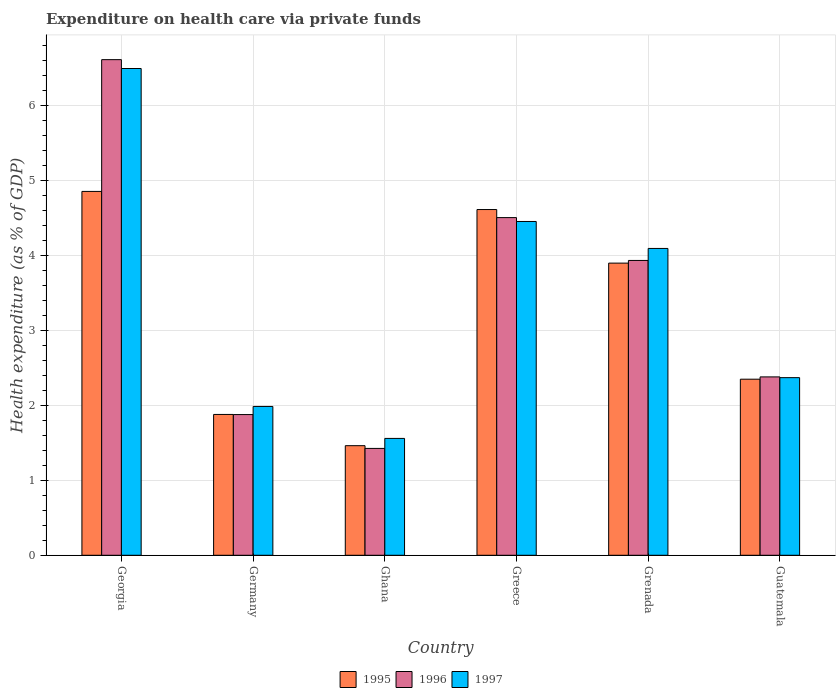How many groups of bars are there?
Ensure brevity in your answer.  6. Are the number of bars per tick equal to the number of legend labels?
Offer a terse response. Yes. How many bars are there on the 1st tick from the left?
Provide a short and direct response. 3. What is the label of the 6th group of bars from the left?
Offer a terse response. Guatemala. In how many cases, is the number of bars for a given country not equal to the number of legend labels?
Offer a very short reply. 0. What is the expenditure made on health care in 1996 in Grenada?
Provide a succinct answer. 3.94. Across all countries, what is the maximum expenditure made on health care in 1996?
Give a very brief answer. 6.62. Across all countries, what is the minimum expenditure made on health care in 1995?
Ensure brevity in your answer.  1.46. In which country was the expenditure made on health care in 1995 maximum?
Your answer should be very brief. Georgia. What is the total expenditure made on health care in 1995 in the graph?
Provide a short and direct response. 19.07. What is the difference between the expenditure made on health care in 1997 in Germany and that in Ghana?
Offer a very short reply. 0.43. What is the difference between the expenditure made on health care in 1997 in Georgia and the expenditure made on health care in 1995 in Greece?
Offer a very short reply. 1.88. What is the average expenditure made on health care in 1995 per country?
Keep it short and to the point. 3.18. What is the difference between the expenditure made on health care of/in 1995 and expenditure made on health care of/in 1997 in Grenada?
Your response must be concise. -0.2. In how many countries, is the expenditure made on health care in 1995 greater than 6.2 %?
Your answer should be compact. 0. What is the ratio of the expenditure made on health care in 1997 in Georgia to that in Grenada?
Provide a short and direct response. 1.59. Is the difference between the expenditure made on health care in 1995 in Ghana and Grenada greater than the difference between the expenditure made on health care in 1997 in Ghana and Grenada?
Keep it short and to the point. Yes. What is the difference between the highest and the second highest expenditure made on health care in 1996?
Your response must be concise. -0.57. What is the difference between the highest and the lowest expenditure made on health care in 1997?
Your response must be concise. 4.94. In how many countries, is the expenditure made on health care in 1995 greater than the average expenditure made on health care in 1995 taken over all countries?
Make the answer very short. 3. Is the sum of the expenditure made on health care in 1997 in Ghana and Greece greater than the maximum expenditure made on health care in 1996 across all countries?
Provide a succinct answer. No. What does the 2nd bar from the right in Germany represents?
Offer a terse response. 1996. How many bars are there?
Offer a terse response. 18. Are all the bars in the graph horizontal?
Ensure brevity in your answer.  No. How many countries are there in the graph?
Make the answer very short. 6. What is the difference between two consecutive major ticks on the Y-axis?
Ensure brevity in your answer.  1. Are the values on the major ticks of Y-axis written in scientific E-notation?
Your answer should be compact. No. Does the graph contain any zero values?
Your answer should be compact. No. How many legend labels are there?
Give a very brief answer. 3. What is the title of the graph?
Provide a short and direct response. Expenditure on health care via private funds. Does "1967" appear as one of the legend labels in the graph?
Offer a very short reply. No. What is the label or title of the Y-axis?
Make the answer very short. Health expenditure (as % of GDP). What is the Health expenditure (as % of GDP) in 1995 in Georgia?
Offer a very short reply. 4.86. What is the Health expenditure (as % of GDP) in 1996 in Georgia?
Keep it short and to the point. 6.62. What is the Health expenditure (as % of GDP) in 1997 in Georgia?
Your answer should be very brief. 6.5. What is the Health expenditure (as % of GDP) in 1995 in Germany?
Your response must be concise. 1.88. What is the Health expenditure (as % of GDP) of 1996 in Germany?
Ensure brevity in your answer.  1.88. What is the Health expenditure (as % of GDP) in 1997 in Germany?
Your response must be concise. 1.99. What is the Health expenditure (as % of GDP) in 1995 in Ghana?
Make the answer very short. 1.46. What is the Health expenditure (as % of GDP) of 1996 in Ghana?
Your response must be concise. 1.43. What is the Health expenditure (as % of GDP) in 1997 in Ghana?
Ensure brevity in your answer.  1.56. What is the Health expenditure (as % of GDP) of 1995 in Greece?
Give a very brief answer. 4.62. What is the Health expenditure (as % of GDP) of 1996 in Greece?
Your answer should be compact. 4.51. What is the Health expenditure (as % of GDP) of 1997 in Greece?
Your answer should be very brief. 4.46. What is the Health expenditure (as % of GDP) in 1995 in Grenada?
Give a very brief answer. 3.9. What is the Health expenditure (as % of GDP) in 1996 in Grenada?
Give a very brief answer. 3.94. What is the Health expenditure (as % of GDP) in 1997 in Grenada?
Provide a succinct answer. 4.1. What is the Health expenditure (as % of GDP) in 1995 in Guatemala?
Provide a short and direct response. 2.35. What is the Health expenditure (as % of GDP) in 1996 in Guatemala?
Give a very brief answer. 2.38. What is the Health expenditure (as % of GDP) in 1997 in Guatemala?
Provide a short and direct response. 2.37. Across all countries, what is the maximum Health expenditure (as % of GDP) of 1995?
Keep it short and to the point. 4.86. Across all countries, what is the maximum Health expenditure (as % of GDP) in 1996?
Provide a succinct answer. 6.62. Across all countries, what is the maximum Health expenditure (as % of GDP) of 1997?
Your answer should be compact. 6.5. Across all countries, what is the minimum Health expenditure (as % of GDP) in 1995?
Keep it short and to the point. 1.46. Across all countries, what is the minimum Health expenditure (as % of GDP) of 1996?
Your answer should be compact. 1.43. Across all countries, what is the minimum Health expenditure (as % of GDP) of 1997?
Make the answer very short. 1.56. What is the total Health expenditure (as % of GDP) of 1995 in the graph?
Your answer should be compact. 19.07. What is the total Health expenditure (as % of GDP) in 1996 in the graph?
Give a very brief answer. 20.75. What is the total Health expenditure (as % of GDP) of 1997 in the graph?
Make the answer very short. 20.97. What is the difference between the Health expenditure (as % of GDP) of 1995 in Georgia and that in Germany?
Ensure brevity in your answer.  2.98. What is the difference between the Health expenditure (as % of GDP) in 1996 in Georgia and that in Germany?
Your answer should be very brief. 4.74. What is the difference between the Health expenditure (as % of GDP) of 1997 in Georgia and that in Germany?
Your answer should be compact. 4.51. What is the difference between the Health expenditure (as % of GDP) of 1995 in Georgia and that in Ghana?
Keep it short and to the point. 3.39. What is the difference between the Health expenditure (as % of GDP) in 1996 in Georgia and that in Ghana?
Give a very brief answer. 5.19. What is the difference between the Health expenditure (as % of GDP) of 1997 in Georgia and that in Ghana?
Provide a succinct answer. 4.94. What is the difference between the Health expenditure (as % of GDP) in 1995 in Georgia and that in Greece?
Give a very brief answer. 0.24. What is the difference between the Health expenditure (as % of GDP) in 1996 in Georgia and that in Greece?
Ensure brevity in your answer.  2.11. What is the difference between the Health expenditure (as % of GDP) of 1997 in Georgia and that in Greece?
Give a very brief answer. 2.04. What is the difference between the Health expenditure (as % of GDP) of 1995 in Georgia and that in Grenada?
Your answer should be compact. 0.96. What is the difference between the Health expenditure (as % of GDP) in 1996 in Georgia and that in Grenada?
Keep it short and to the point. 2.68. What is the difference between the Health expenditure (as % of GDP) in 1997 in Georgia and that in Grenada?
Make the answer very short. 2.4. What is the difference between the Health expenditure (as % of GDP) of 1995 in Georgia and that in Guatemala?
Give a very brief answer. 2.51. What is the difference between the Health expenditure (as % of GDP) in 1996 in Georgia and that in Guatemala?
Ensure brevity in your answer.  4.24. What is the difference between the Health expenditure (as % of GDP) of 1997 in Georgia and that in Guatemala?
Give a very brief answer. 4.13. What is the difference between the Health expenditure (as % of GDP) of 1995 in Germany and that in Ghana?
Offer a very short reply. 0.42. What is the difference between the Health expenditure (as % of GDP) of 1996 in Germany and that in Ghana?
Provide a succinct answer. 0.45. What is the difference between the Health expenditure (as % of GDP) of 1997 in Germany and that in Ghana?
Give a very brief answer. 0.43. What is the difference between the Health expenditure (as % of GDP) of 1995 in Germany and that in Greece?
Provide a short and direct response. -2.74. What is the difference between the Health expenditure (as % of GDP) in 1996 in Germany and that in Greece?
Provide a short and direct response. -2.63. What is the difference between the Health expenditure (as % of GDP) in 1997 in Germany and that in Greece?
Your answer should be very brief. -2.47. What is the difference between the Health expenditure (as % of GDP) of 1995 in Germany and that in Grenada?
Keep it short and to the point. -2.02. What is the difference between the Health expenditure (as % of GDP) of 1996 in Germany and that in Grenada?
Provide a short and direct response. -2.06. What is the difference between the Health expenditure (as % of GDP) in 1997 in Germany and that in Grenada?
Your answer should be compact. -2.11. What is the difference between the Health expenditure (as % of GDP) of 1995 in Germany and that in Guatemala?
Your answer should be compact. -0.47. What is the difference between the Health expenditure (as % of GDP) in 1996 in Germany and that in Guatemala?
Your answer should be very brief. -0.5. What is the difference between the Health expenditure (as % of GDP) in 1997 in Germany and that in Guatemala?
Offer a very short reply. -0.38. What is the difference between the Health expenditure (as % of GDP) in 1995 in Ghana and that in Greece?
Make the answer very short. -3.15. What is the difference between the Health expenditure (as % of GDP) in 1996 in Ghana and that in Greece?
Offer a terse response. -3.08. What is the difference between the Health expenditure (as % of GDP) of 1997 in Ghana and that in Greece?
Offer a very short reply. -2.9. What is the difference between the Health expenditure (as % of GDP) of 1995 in Ghana and that in Grenada?
Ensure brevity in your answer.  -2.44. What is the difference between the Health expenditure (as % of GDP) of 1996 in Ghana and that in Grenada?
Keep it short and to the point. -2.51. What is the difference between the Health expenditure (as % of GDP) of 1997 in Ghana and that in Grenada?
Your answer should be compact. -2.54. What is the difference between the Health expenditure (as % of GDP) in 1995 in Ghana and that in Guatemala?
Provide a short and direct response. -0.89. What is the difference between the Health expenditure (as % of GDP) in 1996 in Ghana and that in Guatemala?
Your answer should be very brief. -0.95. What is the difference between the Health expenditure (as % of GDP) of 1997 in Ghana and that in Guatemala?
Provide a succinct answer. -0.81. What is the difference between the Health expenditure (as % of GDP) in 1995 in Greece and that in Grenada?
Your response must be concise. 0.72. What is the difference between the Health expenditure (as % of GDP) of 1996 in Greece and that in Grenada?
Give a very brief answer. 0.57. What is the difference between the Health expenditure (as % of GDP) in 1997 in Greece and that in Grenada?
Keep it short and to the point. 0.36. What is the difference between the Health expenditure (as % of GDP) of 1995 in Greece and that in Guatemala?
Your response must be concise. 2.26. What is the difference between the Health expenditure (as % of GDP) of 1996 in Greece and that in Guatemala?
Provide a short and direct response. 2.13. What is the difference between the Health expenditure (as % of GDP) in 1997 in Greece and that in Guatemala?
Provide a short and direct response. 2.08. What is the difference between the Health expenditure (as % of GDP) in 1995 in Grenada and that in Guatemala?
Provide a succinct answer. 1.55. What is the difference between the Health expenditure (as % of GDP) in 1996 in Grenada and that in Guatemala?
Offer a terse response. 1.55. What is the difference between the Health expenditure (as % of GDP) in 1997 in Grenada and that in Guatemala?
Ensure brevity in your answer.  1.72. What is the difference between the Health expenditure (as % of GDP) of 1995 in Georgia and the Health expenditure (as % of GDP) of 1996 in Germany?
Keep it short and to the point. 2.98. What is the difference between the Health expenditure (as % of GDP) of 1995 in Georgia and the Health expenditure (as % of GDP) of 1997 in Germany?
Offer a terse response. 2.87. What is the difference between the Health expenditure (as % of GDP) in 1996 in Georgia and the Health expenditure (as % of GDP) in 1997 in Germany?
Offer a terse response. 4.63. What is the difference between the Health expenditure (as % of GDP) in 1995 in Georgia and the Health expenditure (as % of GDP) in 1996 in Ghana?
Your response must be concise. 3.43. What is the difference between the Health expenditure (as % of GDP) in 1995 in Georgia and the Health expenditure (as % of GDP) in 1997 in Ghana?
Provide a succinct answer. 3.3. What is the difference between the Health expenditure (as % of GDP) of 1996 in Georgia and the Health expenditure (as % of GDP) of 1997 in Ghana?
Offer a terse response. 5.06. What is the difference between the Health expenditure (as % of GDP) in 1995 in Georgia and the Health expenditure (as % of GDP) in 1996 in Greece?
Your response must be concise. 0.35. What is the difference between the Health expenditure (as % of GDP) in 1995 in Georgia and the Health expenditure (as % of GDP) in 1997 in Greece?
Provide a short and direct response. 0.4. What is the difference between the Health expenditure (as % of GDP) of 1996 in Georgia and the Health expenditure (as % of GDP) of 1997 in Greece?
Your answer should be very brief. 2.16. What is the difference between the Health expenditure (as % of GDP) in 1995 in Georgia and the Health expenditure (as % of GDP) in 1996 in Grenada?
Provide a short and direct response. 0.92. What is the difference between the Health expenditure (as % of GDP) of 1995 in Georgia and the Health expenditure (as % of GDP) of 1997 in Grenada?
Give a very brief answer. 0.76. What is the difference between the Health expenditure (as % of GDP) of 1996 in Georgia and the Health expenditure (as % of GDP) of 1997 in Grenada?
Offer a very short reply. 2.52. What is the difference between the Health expenditure (as % of GDP) of 1995 in Georgia and the Health expenditure (as % of GDP) of 1996 in Guatemala?
Ensure brevity in your answer.  2.48. What is the difference between the Health expenditure (as % of GDP) of 1995 in Georgia and the Health expenditure (as % of GDP) of 1997 in Guatemala?
Ensure brevity in your answer.  2.49. What is the difference between the Health expenditure (as % of GDP) in 1996 in Georgia and the Health expenditure (as % of GDP) in 1997 in Guatemala?
Offer a terse response. 4.25. What is the difference between the Health expenditure (as % of GDP) of 1995 in Germany and the Health expenditure (as % of GDP) of 1996 in Ghana?
Offer a terse response. 0.45. What is the difference between the Health expenditure (as % of GDP) of 1995 in Germany and the Health expenditure (as % of GDP) of 1997 in Ghana?
Ensure brevity in your answer.  0.32. What is the difference between the Health expenditure (as % of GDP) in 1996 in Germany and the Health expenditure (as % of GDP) in 1997 in Ghana?
Provide a succinct answer. 0.32. What is the difference between the Health expenditure (as % of GDP) in 1995 in Germany and the Health expenditure (as % of GDP) in 1996 in Greece?
Keep it short and to the point. -2.63. What is the difference between the Health expenditure (as % of GDP) in 1995 in Germany and the Health expenditure (as % of GDP) in 1997 in Greece?
Offer a very short reply. -2.58. What is the difference between the Health expenditure (as % of GDP) in 1996 in Germany and the Health expenditure (as % of GDP) in 1997 in Greece?
Give a very brief answer. -2.58. What is the difference between the Health expenditure (as % of GDP) in 1995 in Germany and the Health expenditure (as % of GDP) in 1996 in Grenada?
Make the answer very short. -2.06. What is the difference between the Health expenditure (as % of GDP) of 1995 in Germany and the Health expenditure (as % of GDP) of 1997 in Grenada?
Provide a succinct answer. -2.22. What is the difference between the Health expenditure (as % of GDP) in 1996 in Germany and the Health expenditure (as % of GDP) in 1997 in Grenada?
Provide a succinct answer. -2.22. What is the difference between the Health expenditure (as % of GDP) in 1995 in Germany and the Health expenditure (as % of GDP) in 1996 in Guatemala?
Give a very brief answer. -0.5. What is the difference between the Health expenditure (as % of GDP) of 1995 in Germany and the Health expenditure (as % of GDP) of 1997 in Guatemala?
Provide a succinct answer. -0.49. What is the difference between the Health expenditure (as % of GDP) of 1996 in Germany and the Health expenditure (as % of GDP) of 1997 in Guatemala?
Your answer should be compact. -0.49. What is the difference between the Health expenditure (as % of GDP) in 1995 in Ghana and the Health expenditure (as % of GDP) in 1996 in Greece?
Keep it short and to the point. -3.05. What is the difference between the Health expenditure (as % of GDP) in 1995 in Ghana and the Health expenditure (as % of GDP) in 1997 in Greece?
Keep it short and to the point. -2.99. What is the difference between the Health expenditure (as % of GDP) in 1996 in Ghana and the Health expenditure (as % of GDP) in 1997 in Greece?
Keep it short and to the point. -3.03. What is the difference between the Health expenditure (as % of GDP) in 1995 in Ghana and the Health expenditure (as % of GDP) in 1996 in Grenada?
Give a very brief answer. -2.47. What is the difference between the Health expenditure (as % of GDP) in 1995 in Ghana and the Health expenditure (as % of GDP) in 1997 in Grenada?
Provide a short and direct response. -2.63. What is the difference between the Health expenditure (as % of GDP) of 1996 in Ghana and the Health expenditure (as % of GDP) of 1997 in Grenada?
Your answer should be very brief. -2.67. What is the difference between the Health expenditure (as % of GDP) of 1995 in Ghana and the Health expenditure (as % of GDP) of 1996 in Guatemala?
Offer a terse response. -0.92. What is the difference between the Health expenditure (as % of GDP) in 1995 in Ghana and the Health expenditure (as % of GDP) in 1997 in Guatemala?
Give a very brief answer. -0.91. What is the difference between the Health expenditure (as % of GDP) of 1996 in Ghana and the Health expenditure (as % of GDP) of 1997 in Guatemala?
Your answer should be very brief. -0.94. What is the difference between the Health expenditure (as % of GDP) in 1995 in Greece and the Health expenditure (as % of GDP) in 1996 in Grenada?
Offer a terse response. 0.68. What is the difference between the Health expenditure (as % of GDP) in 1995 in Greece and the Health expenditure (as % of GDP) in 1997 in Grenada?
Give a very brief answer. 0.52. What is the difference between the Health expenditure (as % of GDP) in 1996 in Greece and the Health expenditure (as % of GDP) in 1997 in Grenada?
Your answer should be very brief. 0.41. What is the difference between the Health expenditure (as % of GDP) of 1995 in Greece and the Health expenditure (as % of GDP) of 1996 in Guatemala?
Make the answer very short. 2.23. What is the difference between the Health expenditure (as % of GDP) in 1995 in Greece and the Health expenditure (as % of GDP) in 1997 in Guatemala?
Your response must be concise. 2.24. What is the difference between the Health expenditure (as % of GDP) in 1996 in Greece and the Health expenditure (as % of GDP) in 1997 in Guatemala?
Keep it short and to the point. 2.14. What is the difference between the Health expenditure (as % of GDP) of 1995 in Grenada and the Health expenditure (as % of GDP) of 1996 in Guatemala?
Your answer should be compact. 1.52. What is the difference between the Health expenditure (as % of GDP) in 1995 in Grenada and the Health expenditure (as % of GDP) in 1997 in Guatemala?
Your response must be concise. 1.53. What is the difference between the Health expenditure (as % of GDP) of 1996 in Grenada and the Health expenditure (as % of GDP) of 1997 in Guatemala?
Keep it short and to the point. 1.56. What is the average Health expenditure (as % of GDP) in 1995 per country?
Offer a terse response. 3.18. What is the average Health expenditure (as % of GDP) of 1996 per country?
Offer a terse response. 3.46. What is the average Health expenditure (as % of GDP) in 1997 per country?
Give a very brief answer. 3.5. What is the difference between the Health expenditure (as % of GDP) in 1995 and Health expenditure (as % of GDP) in 1996 in Georgia?
Your response must be concise. -1.76. What is the difference between the Health expenditure (as % of GDP) in 1995 and Health expenditure (as % of GDP) in 1997 in Georgia?
Offer a very short reply. -1.64. What is the difference between the Health expenditure (as % of GDP) of 1996 and Health expenditure (as % of GDP) of 1997 in Georgia?
Your answer should be very brief. 0.12. What is the difference between the Health expenditure (as % of GDP) in 1995 and Health expenditure (as % of GDP) in 1996 in Germany?
Your answer should be very brief. 0. What is the difference between the Health expenditure (as % of GDP) of 1995 and Health expenditure (as % of GDP) of 1997 in Germany?
Your answer should be very brief. -0.11. What is the difference between the Health expenditure (as % of GDP) of 1996 and Health expenditure (as % of GDP) of 1997 in Germany?
Keep it short and to the point. -0.11. What is the difference between the Health expenditure (as % of GDP) of 1995 and Health expenditure (as % of GDP) of 1996 in Ghana?
Provide a short and direct response. 0.04. What is the difference between the Health expenditure (as % of GDP) of 1995 and Health expenditure (as % of GDP) of 1997 in Ghana?
Provide a succinct answer. -0.1. What is the difference between the Health expenditure (as % of GDP) of 1996 and Health expenditure (as % of GDP) of 1997 in Ghana?
Your answer should be very brief. -0.13. What is the difference between the Health expenditure (as % of GDP) of 1995 and Health expenditure (as % of GDP) of 1996 in Greece?
Your answer should be compact. 0.11. What is the difference between the Health expenditure (as % of GDP) in 1995 and Health expenditure (as % of GDP) in 1997 in Greece?
Ensure brevity in your answer.  0.16. What is the difference between the Health expenditure (as % of GDP) in 1996 and Health expenditure (as % of GDP) in 1997 in Greece?
Provide a succinct answer. 0.05. What is the difference between the Health expenditure (as % of GDP) of 1995 and Health expenditure (as % of GDP) of 1996 in Grenada?
Offer a very short reply. -0.04. What is the difference between the Health expenditure (as % of GDP) in 1995 and Health expenditure (as % of GDP) in 1997 in Grenada?
Provide a succinct answer. -0.2. What is the difference between the Health expenditure (as % of GDP) of 1996 and Health expenditure (as % of GDP) of 1997 in Grenada?
Provide a short and direct response. -0.16. What is the difference between the Health expenditure (as % of GDP) of 1995 and Health expenditure (as % of GDP) of 1996 in Guatemala?
Make the answer very short. -0.03. What is the difference between the Health expenditure (as % of GDP) in 1995 and Health expenditure (as % of GDP) in 1997 in Guatemala?
Provide a succinct answer. -0.02. What is the ratio of the Health expenditure (as % of GDP) of 1995 in Georgia to that in Germany?
Provide a succinct answer. 2.58. What is the ratio of the Health expenditure (as % of GDP) in 1996 in Georgia to that in Germany?
Ensure brevity in your answer.  3.52. What is the ratio of the Health expenditure (as % of GDP) in 1997 in Georgia to that in Germany?
Provide a short and direct response. 3.27. What is the ratio of the Health expenditure (as % of GDP) in 1995 in Georgia to that in Ghana?
Make the answer very short. 3.32. What is the ratio of the Health expenditure (as % of GDP) in 1996 in Georgia to that in Ghana?
Your answer should be very brief. 4.64. What is the ratio of the Health expenditure (as % of GDP) in 1997 in Georgia to that in Ghana?
Keep it short and to the point. 4.17. What is the ratio of the Health expenditure (as % of GDP) in 1995 in Georgia to that in Greece?
Offer a very short reply. 1.05. What is the ratio of the Health expenditure (as % of GDP) of 1996 in Georgia to that in Greece?
Your answer should be very brief. 1.47. What is the ratio of the Health expenditure (as % of GDP) in 1997 in Georgia to that in Greece?
Keep it short and to the point. 1.46. What is the ratio of the Health expenditure (as % of GDP) in 1995 in Georgia to that in Grenada?
Ensure brevity in your answer.  1.25. What is the ratio of the Health expenditure (as % of GDP) of 1996 in Georgia to that in Grenada?
Offer a very short reply. 1.68. What is the ratio of the Health expenditure (as % of GDP) of 1997 in Georgia to that in Grenada?
Offer a very short reply. 1.59. What is the ratio of the Health expenditure (as % of GDP) in 1995 in Georgia to that in Guatemala?
Provide a short and direct response. 2.07. What is the ratio of the Health expenditure (as % of GDP) in 1996 in Georgia to that in Guatemala?
Provide a succinct answer. 2.78. What is the ratio of the Health expenditure (as % of GDP) in 1997 in Georgia to that in Guatemala?
Provide a succinct answer. 2.74. What is the ratio of the Health expenditure (as % of GDP) of 1995 in Germany to that in Ghana?
Offer a terse response. 1.29. What is the ratio of the Health expenditure (as % of GDP) in 1996 in Germany to that in Ghana?
Give a very brief answer. 1.32. What is the ratio of the Health expenditure (as % of GDP) of 1997 in Germany to that in Ghana?
Keep it short and to the point. 1.27. What is the ratio of the Health expenditure (as % of GDP) of 1995 in Germany to that in Greece?
Offer a very short reply. 0.41. What is the ratio of the Health expenditure (as % of GDP) of 1996 in Germany to that in Greece?
Provide a succinct answer. 0.42. What is the ratio of the Health expenditure (as % of GDP) of 1997 in Germany to that in Greece?
Offer a very short reply. 0.45. What is the ratio of the Health expenditure (as % of GDP) of 1995 in Germany to that in Grenada?
Offer a very short reply. 0.48. What is the ratio of the Health expenditure (as % of GDP) in 1996 in Germany to that in Grenada?
Your answer should be very brief. 0.48. What is the ratio of the Health expenditure (as % of GDP) of 1997 in Germany to that in Grenada?
Keep it short and to the point. 0.49. What is the ratio of the Health expenditure (as % of GDP) in 1995 in Germany to that in Guatemala?
Ensure brevity in your answer.  0.8. What is the ratio of the Health expenditure (as % of GDP) in 1996 in Germany to that in Guatemala?
Ensure brevity in your answer.  0.79. What is the ratio of the Health expenditure (as % of GDP) of 1997 in Germany to that in Guatemala?
Give a very brief answer. 0.84. What is the ratio of the Health expenditure (as % of GDP) of 1995 in Ghana to that in Greece?
Make the answer very short. 0.32. What is the ratio of the Health expenditure (as % of GDP) of 1996 in Ghana to that in Greece?
Your answer should be compact. 0.32. What is the ratio of the Health expenditure (as % of GDP) in 1997 in Ghana to that in Greece?
Your answer should be very brief. 0.35. What is the ratio of the Health expenditure (as % of GDP) of 1995 in Ghana to that in Grenada?
Your answer should be very brief. 0.38. What is the ratio of the Health expenditure (as % of GDP) of 1996 in Ghana to that in Grenada?
Keep it short and to the point. 0.36. What is the ratio of the Health expenditure (as % of GDP) in 1997 in Ghana to that in Grenada?
Give a very brief answer. 0.38. What is the ratio of the Health expenditure (as % of GDP) of 1995 in Ghana to that in Guatemala?
Your answer should be very brief. 0.62. What is the ratio of the Health expenditure (as % of GDP) of 1996 in Ghana to that in Guatemala?
Provide a short and direct response. 0.6. What is the ratio of the Health expenditure (as % of GDP) of 1997 in Ghana to that in Guatemala?
Your answer should be very brief. 0.66. What is the ratio of the Health expenditure (as % of GDP) of 1995 in Greece to that in Grenada?
Give a very brief answer. 1.18. What is the ratio of the Health expenditure (as % of GDP) in 1996 in Greece to that in Grenada?
Ensure brevity in your answer.  1.15. What is the ratio of the Health expenditure (as % of GDP) of 1997 in Greece to that in Grenada?
Your answer should be very brief. 1.09. What is the ratio of the Health expenditure (as % of GDP) in 1995 in Greece to that in Guatemala?
Offer a terse response. 1.96. What is the ratio of the Health expenditure (as % of GDP) in 1996 in Greece to that in Guatemala?
Provide a succinct answer. 1.89. What is the ratio of the Health expenditure (as % of GDP) of 1997 in Greece to that in Guatemala?
Keep it short and to the point. 1.88. What is the ratio of the Health expenditure (as % of GDP) in 1995 in Grenada to that in Guatemala?
Your answer should be very brief. 1.66. What is the ratio of the Health expenditure (as % of GDP) of 1996 in Grenada to that in Guatemala?
Offer a terse response. 1.65. What is the ratio of the Health expenditure (as % of GDP) of 1997 in Grenada to that in Guatemala?
Ensure brevity in your answer.  1.73. What is the difference between the highest and the second highest Health expenditure (as % of GDP) of 1995?
Your response must be concise. 0.24. What is the difference between the highest and the second highest Health expenditure (as % of GDP) of 1996?
Provide a short and direct response. 2.11. What is the difference between the highest and the second highest Health expenditure (as % of GDP) of 1997?
Offer a terse response. 2.04. What is the difference between the highest and the lowest Health expenditure (as % of GDP) of 1995?
Your response must be concise. 3.39. What is the difference between the highest and the lowest Health expenditure (as % of GDP) in 1996?
Keep it short and to the point. 5.19. What is the difference between the highest and the lowest Health expenditure (as % of GDP) of 1997?
Your response must be concise. 4.94. 